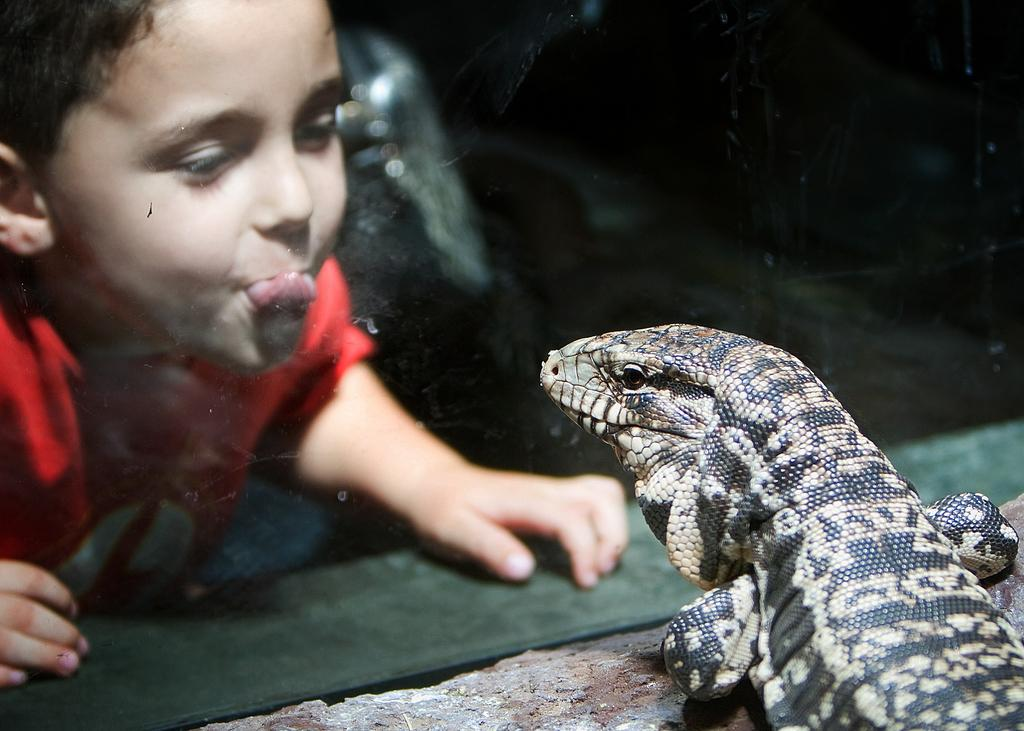What type of animal is on the surface in the image? There is a reptile on the surface in the image. What is in front of the reptile? There is a glass in front of the reptile. What can be seen through the glass? A boy is visible through the glass. How would you describe the lighting in the image? The image appears to be dark. What letter is the reptile writing with ink on the surface? There is no letter or ink present in the image; the reptile is simply on the surface. 